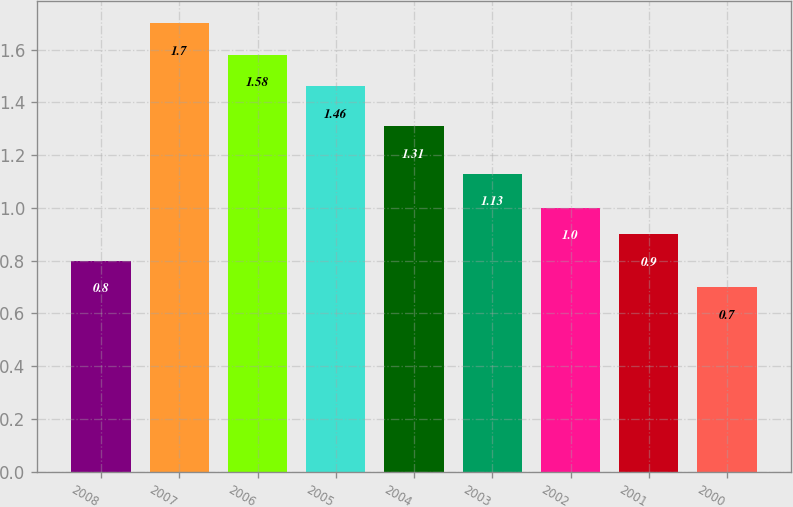Convert chart. <chart><loc_0><loc_0><loc_500><loc_500><bar_chart><fcel>2008<fcel>2007<fcel>2006<fcel>2005<fcel>2004<fcel>2003<fcel>2002<fcel>2001<fcel>2000<nl><fcel>0.8<fcel>1.7<fcel>1.58<fcel>1.46<fcel>1.31<fcel>1.13<fcel>1<fcel>0.9<fcel>0.7<nl></chart> 